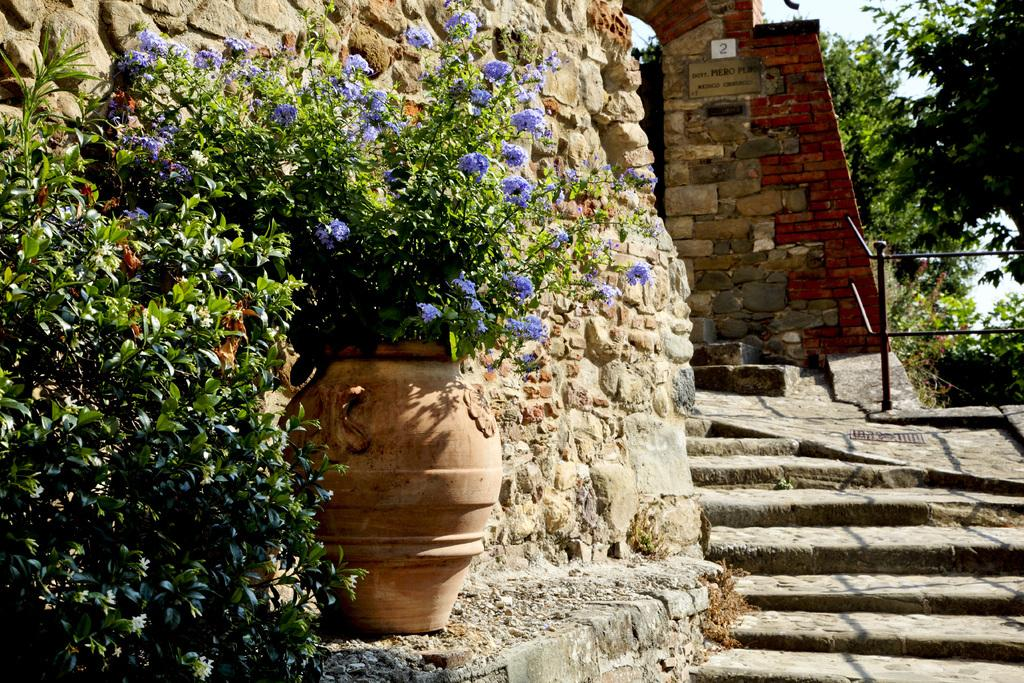What type of vegetation can be seen in the image? There are trees and plants with flowers in the image. What structure is present in the image? There is a monument in the image. Can you describe the type of plant in a pot in the image? There is a plant in a pot in the image. What type of shoes can be seen on the monument in the image? There are no shoes present on the monument in the image. What type of collar is visible on the plant in the pot in the image? There is no collar present on the plant in the pot in the image. 